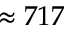Convert formula to latex. <formula><loc_0><loc_0><loc_500><loc_500>\approx 7 1 7</formula> 